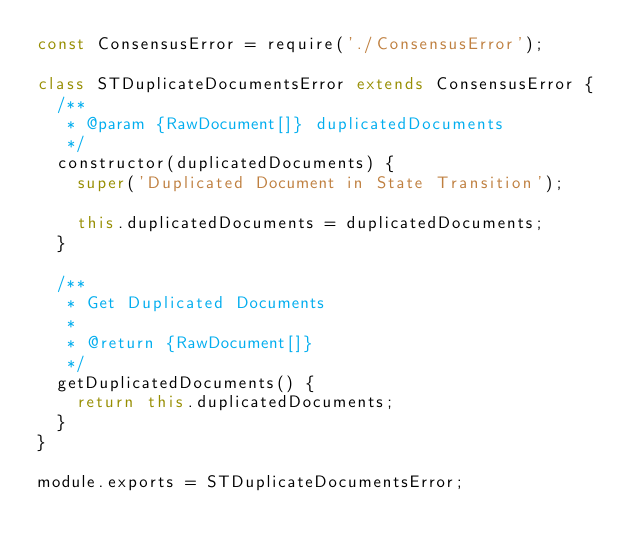<code> <loc_0><loc_0><loc_500><loc_500><_JavaScript_>const ConsensusError = require('./ConsensusError');

class STDuplicateDocumentsError extends ConsensusError {
  /**
   * @param {RawDocument[]} duplicatedDocuments
   */
  constructor(duplicatedDocuments) {
    super('Duplicated Document in State Transition');

    this.duplicatedDocuments = duplicatedDocuments;
  }

  /**
   * Get Duplicated Documents
   *
   * @return {RawDocument[]}
   */
  getDuplicatedDocuments() {
    return this.duplicatedDocuments;
  }
}

module.exports = STDuplicateDocumentsError;
</code> 